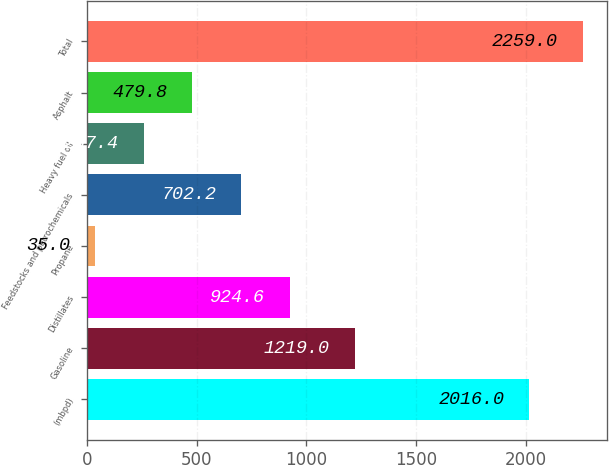Convert chart to OTSL. <chart><loc_0><loc_0><loc_500><loc_500><bar_chart><fcel>(mbpd)<fcel>Gasoline<fcel>Distillates<fcel>Propane<fcel>Feedstocks and petrochemicals<fcel>Heavy fuel oil<fcel>Asphalt<fcel>Total<nl><fcel>2016<fcel>1219<fcel>924.6<fcel>35<fcel>702.2<fcel>257.4<fcel>479.8<fcel>2259<nl></chart> 